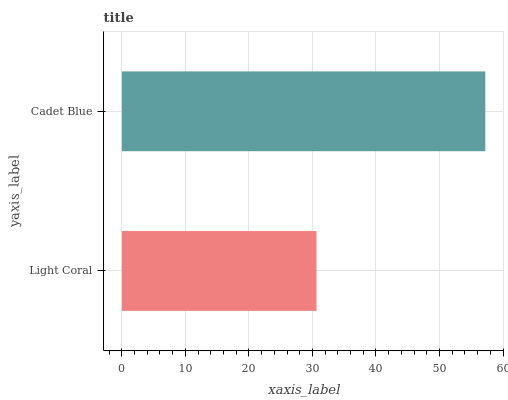Is Light Coral the minimum?
Answer yes or no. Yes. Is Cadet Blue the maximum?
Answer yes or no. Yes. Is Cadet Blue the minimum?
Answer yes or no. No. Is Cadet Blue greater than Light Coral?
Answer yes or no. Yes. Is Light Coral less than Cadet Blue?
Answer yes or no. Yes. Is Light Coral greater than Cadet Blue?
Answer yes or no. No. Is Cadet Blue less than Light Coral?
Answer yes or no. No. Is Cadet Blue the high median?
Answer yes or no. Yes. Is Light Coral the low median?
Answer yes or no. Yes. Is Light Coral the high median?
Answer yes or no. No. Is Cadet Blue the low median?
Answer yes or no. No. 